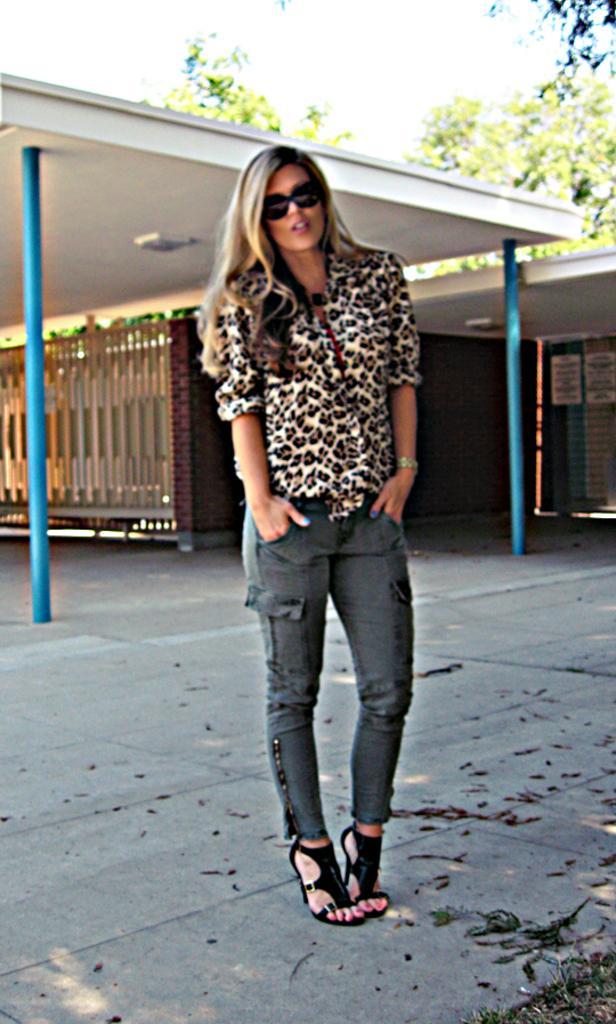Describe this image in one or two sentences. In the middle of the picture, we see the woman is standing. She is wearing the goggles. She is posing for the photo. Behind her, we see the poles and the wooden wall. We even see the roof of the building. There are trees in the background. At the top, we see the sky. 